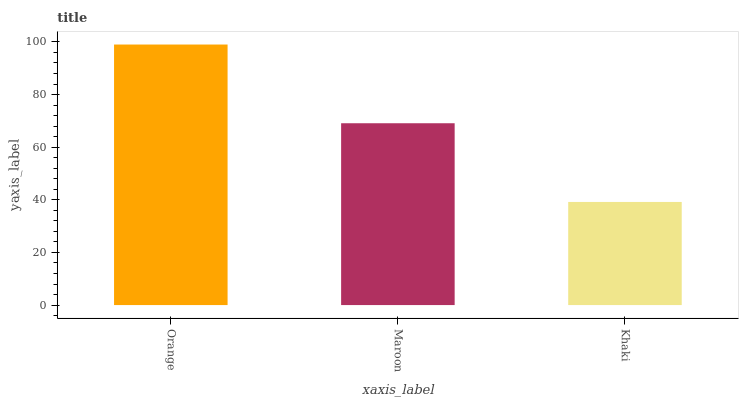Is Khaki the minimum?
Answer yes or no. Yes. Is Orange the maximum?
Answer yes or no. Yes. Is Maroon the minimum?
Answer yes or no. No. Is Maroon the maximum?
Answer yes or no. No. Is Orange greater than Maroon?
Answer yes or no. Yes. Is Maroon less than Orange?
Answer yes or no. Yes. Is Maroon greater than Orange?
Answer yes or no. No. Is Orange less than Maroon?
Answer yes or no. No. Is Maroon the high median?
Answer yes or no. Yes. Is Maroon the low median?
Answer yes or no. Yes. Is Orange the high median?
Answer yes or no. No. Is Khaki the low median?
Answer yes or no. No. 